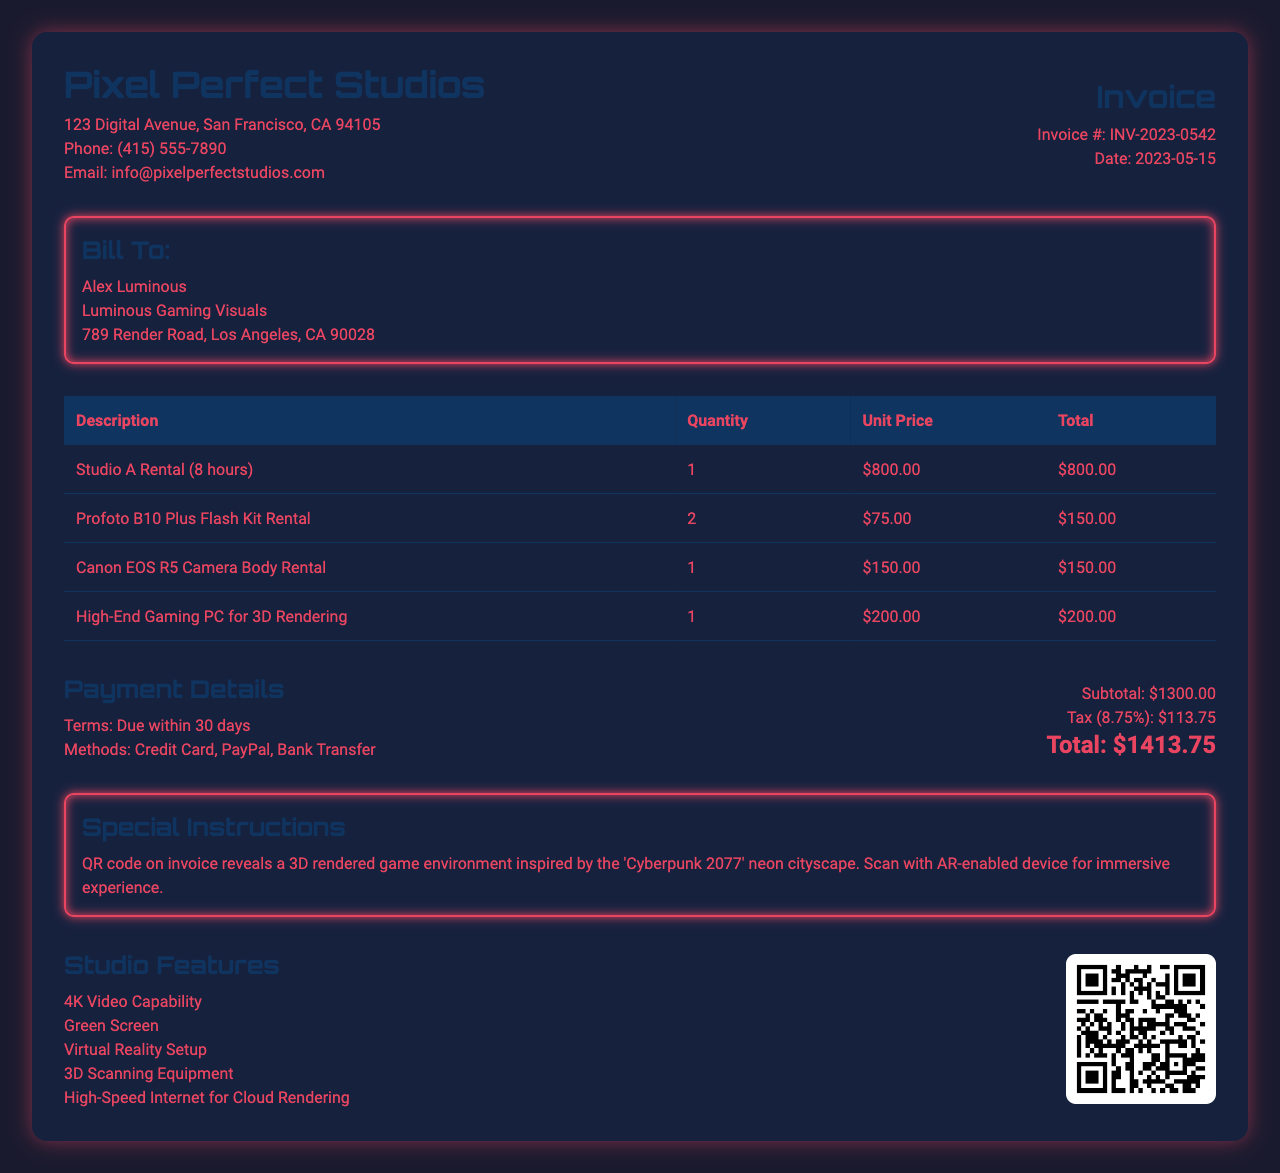What is the invoice number? The invoice number is specifically mentioned in the document as a unique identifier for the invoice.
Answer: INV-2023-0542 What is the total amount due? The total amount due is calculated based on the subtotal and tax indicated in the invoice.
Answer: $1413.75 Who is the client company? The client company name appears in the "Bill To" section of the document, stating who is receiving the invoice.
Answer: Luminous Gaming Visuals What items were rented? The document lists the rented items in a table, detailing each item individually.
Answer: Studio A Rental, Profoto B10 Plus Flash Kit, Canon EOS R5, High-End Gaming PC What is the tax rate? The tax rate is specifically mentioned in the payment details section, providing information about the applied tax percentage.
Answer: 8.75% What is the payment term for this invoice? The payment terms are specified in the document, indicating the amount of time the client has to settle the invoice.
Answer: Due within 30 days How many hours was Studio A rented? The duration for the rental of Studio A is specified directly in the item description on the invoice.
Answer: 8 hours Which special instruction is provided in the document? The special instructions section contains unique information related to scanning the QR code for an additional feature.
Answer: QR code on invoice reveals a 3D rendered game environment What additional services are offered? The document mentions extra services that can be availed apart from the main rental.
Answer: 3D Environment Consultation, Post-Production Retouching 